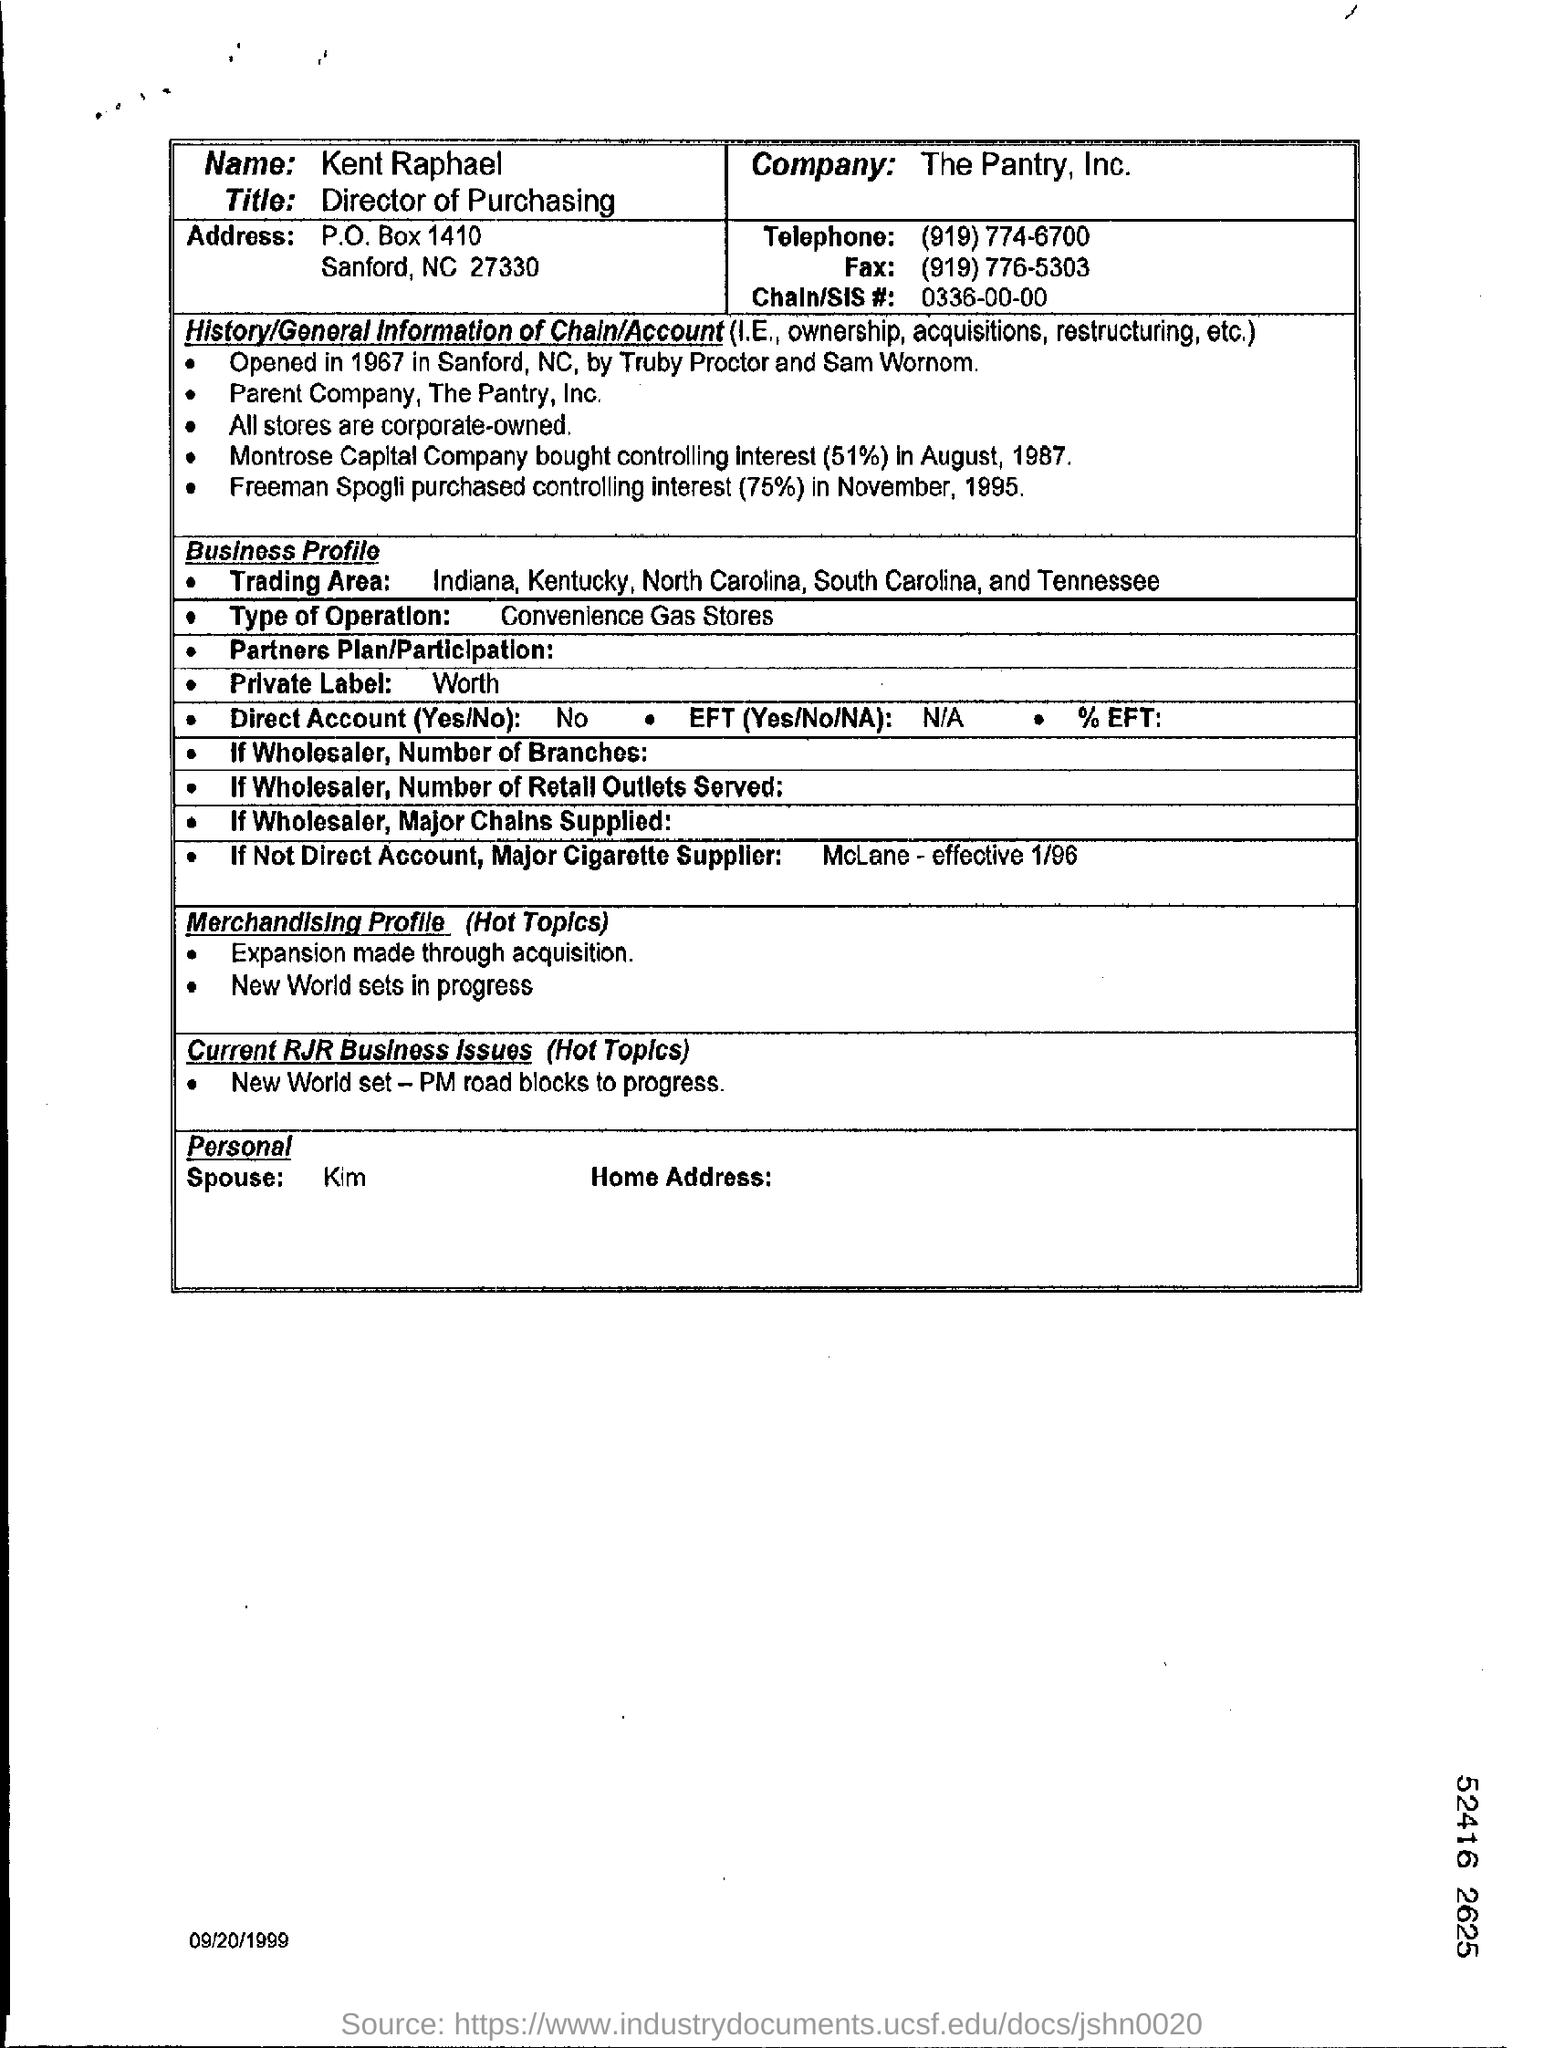What is the Name?
Your answer should be compact. Kent Raphael. What is the Title?
Your answer should be very brief. Director of purchasing. Which is the company?
Ensure brevity in your answer.  The Pantry, Inc. What is the Telephone?
Your response must be concise. (919) 774-6700. What is the Fax?
Your response must be concise. (919) 776-5303. What is the Chain/SIS #?
Provide a succinct answer. 0336-00-00. 